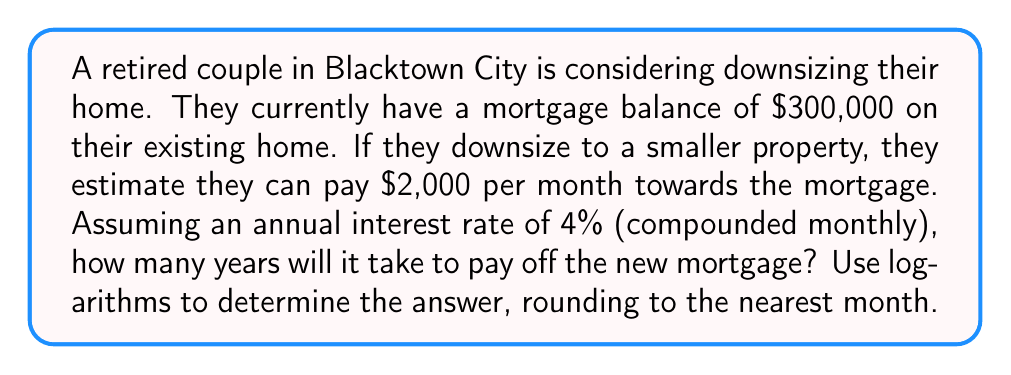Solve this math problem. To solve this problem, we'll use the compound interest formula for loan repayment:

$$A = P \cdot \frac{r(1+r)^n}{(1+r)^n - 1}$$

Where:
$A$ = monthly payment
$P$ = principal (loan amount)
$r$ = monthly interest rate
$n$ = number of monthly payments

We know:
$A = \$2,000$
$P = \$300,000$
Annual interest rate = 4% = 0.04
$r = \frac{0.04}{12} = \frac{1}{300}$ (monthly rate)

Substituting these values:

$$2000 = 300000 \cdot \frac{\frac{1}{300}(1+\frac{1}{300})^n}{(1+\frac{1}{300})^n - 1}$$

Simplifying:

$$\frac{1}{150} = \frac{(1+\frac{1}{300})^n - 1}{(1+\frac{1}{300})^n}$$

$$\frac{149}{150} = (1+\frac{1}{300})^n$$

Taking the natural logarithm of both sides:

$$\ln(\frac{149}{150}) = n \cdot \ln(1+\frac{1}{300})$$

Solving for $n$:

$$n = \frac{\ln(\frac{149}{150})}{\ln(1+\frac{1}{300})}$$

Using a calculator:

$$n \approx 180.76$$

This represents the number of monthly payments. To convert to years, divide by 12:

$$\text{Years} = \frac{180.76}{12} \approx 15.06$$

Rounding to the nearest month, we get 15 years and 1 month.
Answer: It will take approximately 15 years and 1 month to pay off the new mortgage. 